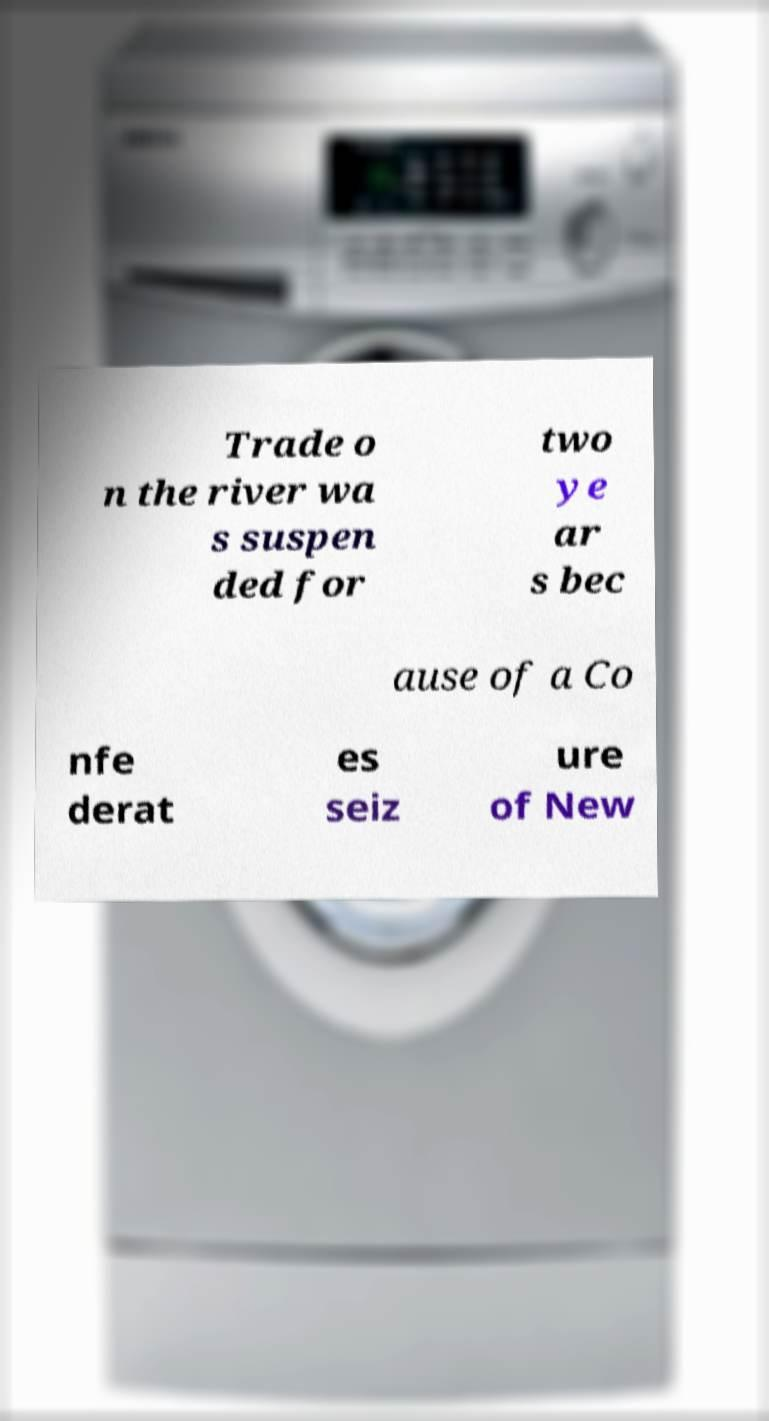For documentation purposes, I need the text within this image transcribed. Could you provide that? Trade o n the river wa s suspen ded for two ye ar s bec ause of a Co nfe derat es seiz ure of New 